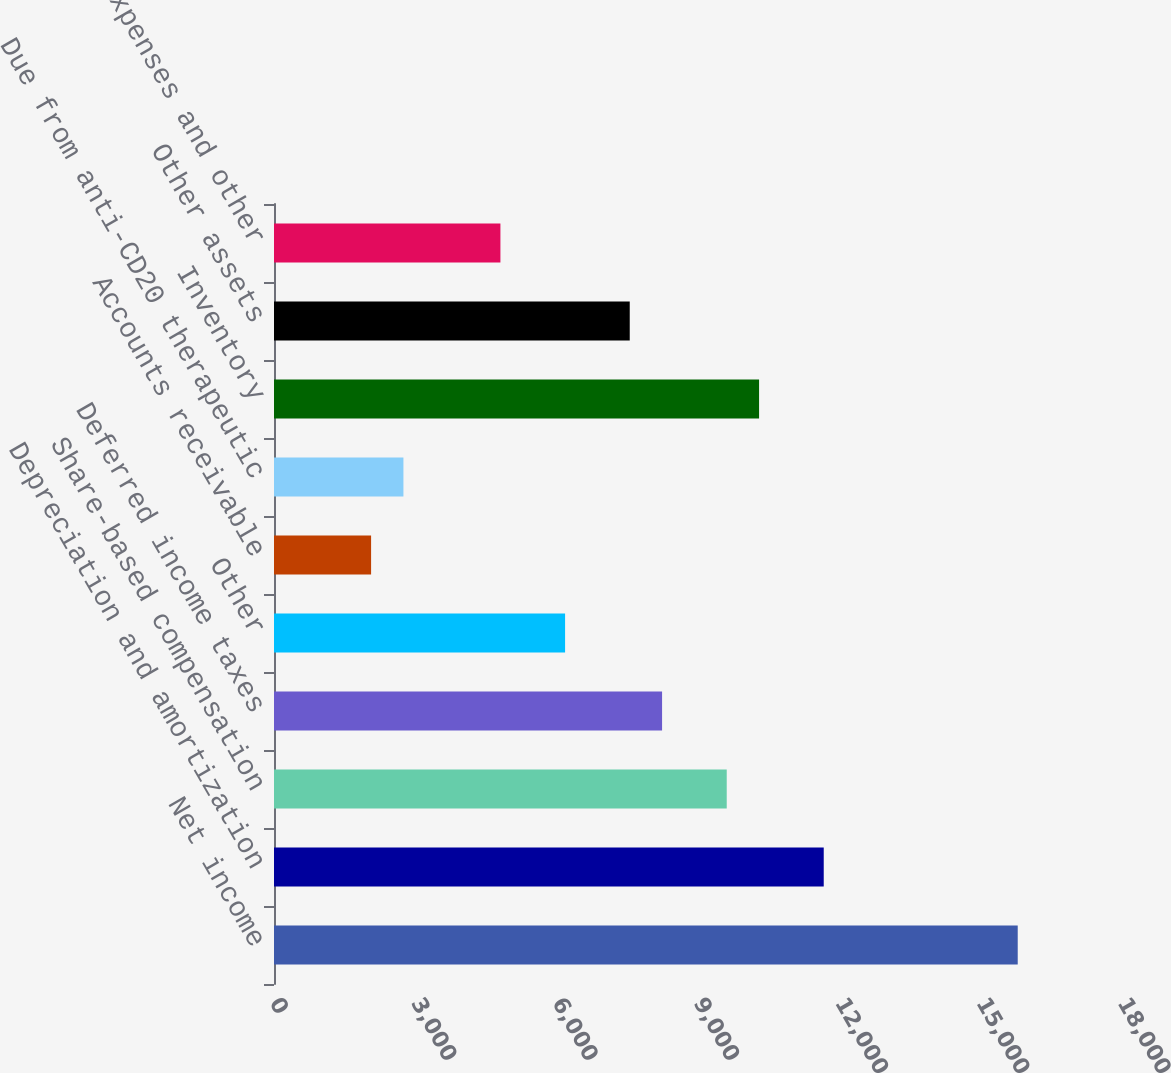<chart> <loc_0><loc_0><loc_500><loc_500><bar_chart><fcel>Net income<fcel>Depreciation and amortization<fcel>Share-based compensation<fcel>Deferred income taxes<fcel>Other<fcel>Accounts receivable<fcel>Due from anti-CD20 therapeutic<fcel>Inventory<fcel>Other assets<fcel>Accrued expenses and other<nl><fcel>15786.5<fcel>11668.9<fcel>9610.02<fcel>8237.46<fcel>6178.62<fcel>2060.94<fcel>2747.22<fcel>10296.3<fcel>7551.18<fcel>4806.06<nl></chart> 